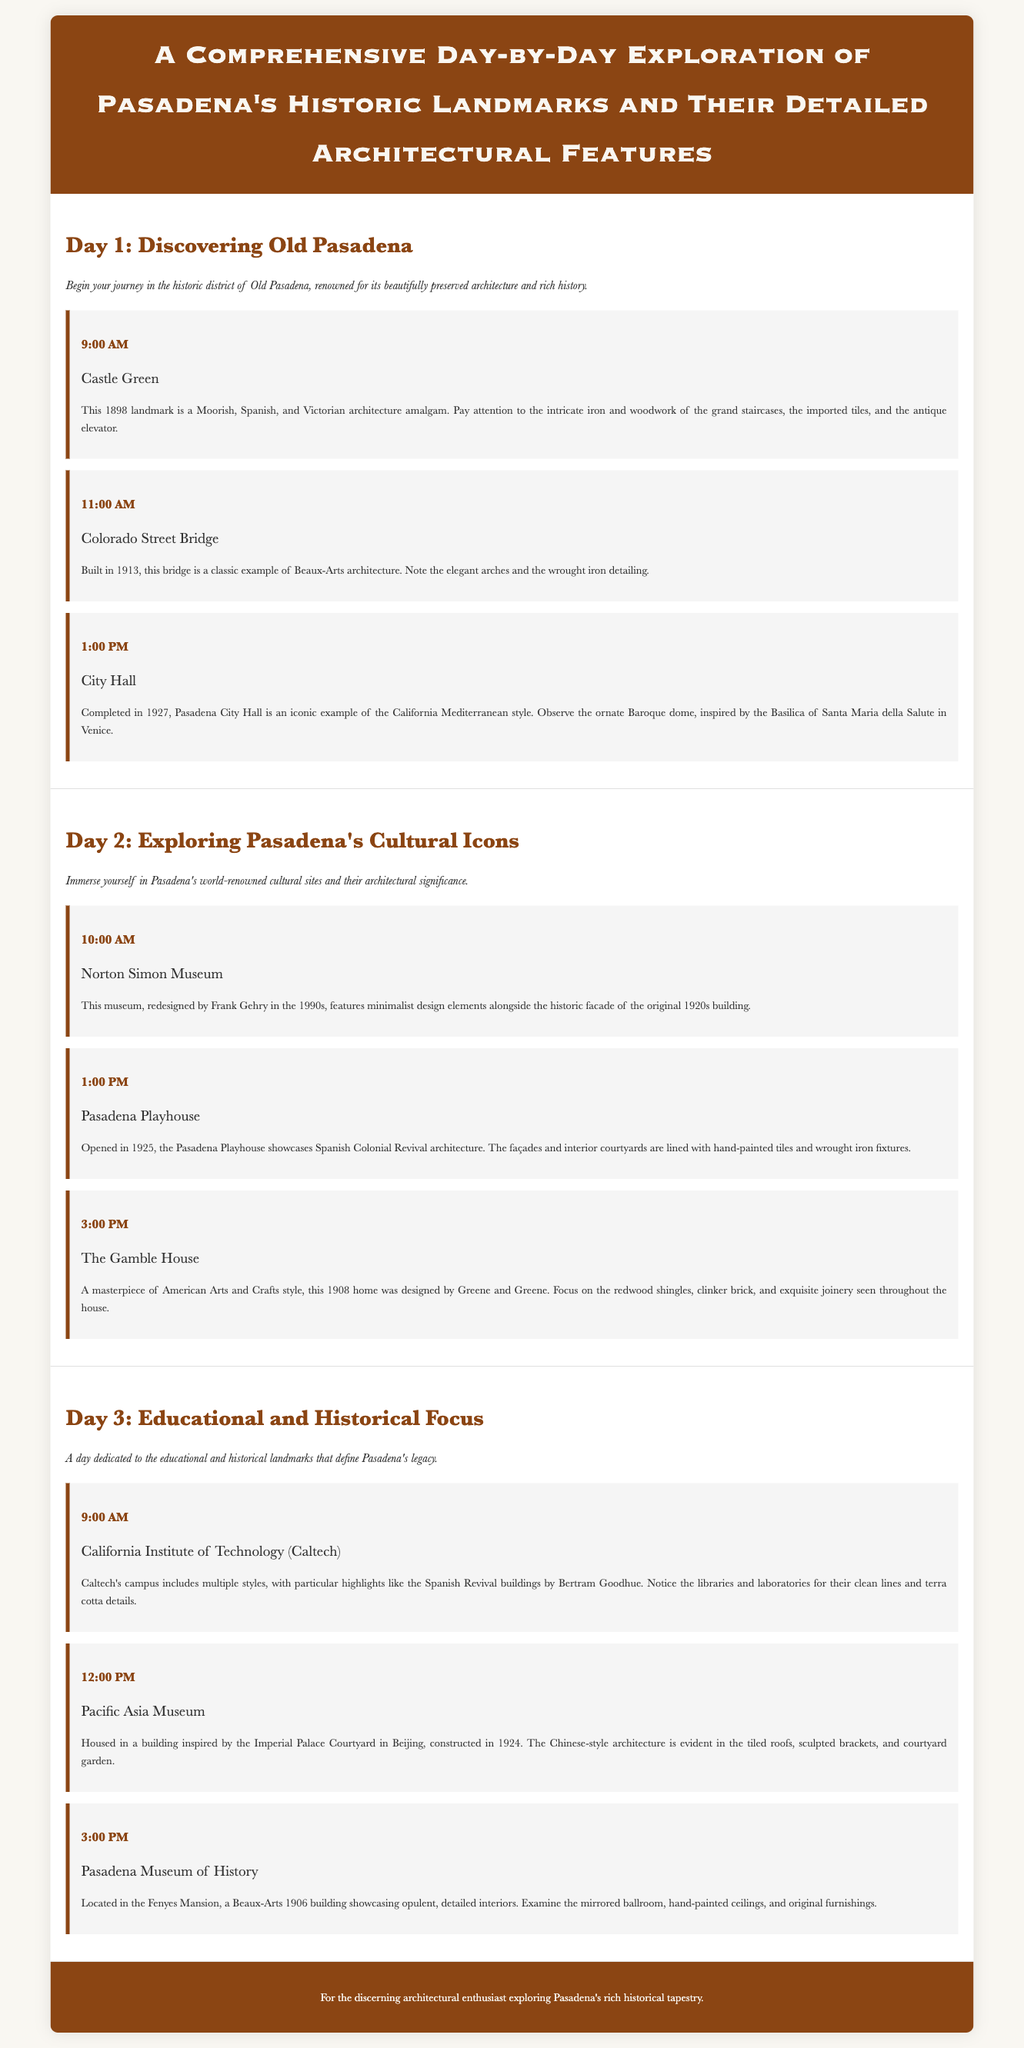What is the title of the itinerary? The title is stated at the top of the document, indicating the focus on Pasadena's landmarks and their architectural features.
Answer: A Comprehensive Day-by-Day Exploration of Pasadena's Historic Landmarks and Their Detailed Architectural Features What architectural style is Pasadena City Hall primarily associated with? The description provided indicates that Pasadena City Hall is identified as an example of the California Mediterranean style.
Answer: California Mediterranean What year was the Castle Green built? The document specifies that Castle Green was built in 1898.
Answer: 1898 At what time does the tour of The Gamble House begin? The schedule indicates that the activity at The Gamble House is set for 3:00 PM on Day 2.
Answer: 3:00 PM What is notable about the roof design of the Pacific Asia Museum? The details note that the architecture features tiled roofs, which imply a specific aesthetic characteristic.
Answer: Tiled roofs How many days does the itinerary cover? The structure of the document reveals three separate days of planned activities for the exploration.
Answer: Three What architectural feature is emphasized in the Colorado Street Bridge? The document refers to the elegant arches as a key feature of the bridge's design.
Answer: Elegant arches Which landmark is associated with Frank Gehry's redesign? The information in the document links the Norton Simon Museum to its redesign by Frank Gehry.
Answer: Norton Simon Museum What is the opening year of the Pasadena Playhouse? The itinerary indicates that the Pasadena Playhouse was opened in 1925.
Answer: 1925 